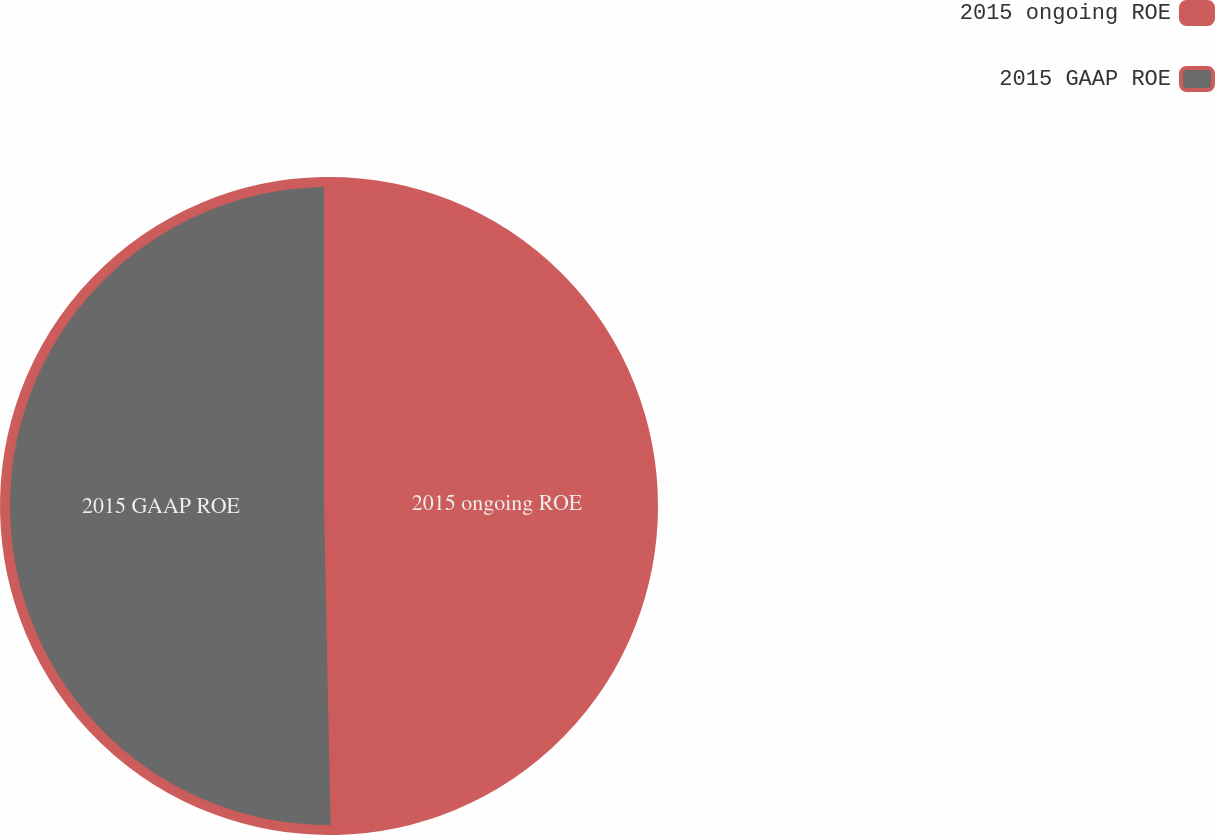<chart> <loc_0><loc_0><loc_500><loc_500><pie_chart><fcel>2015 ongoing ROE<fcel>2015 GAAP ROE<nl><fcel>49.67%<fcel>50.33%<nl></chart> 